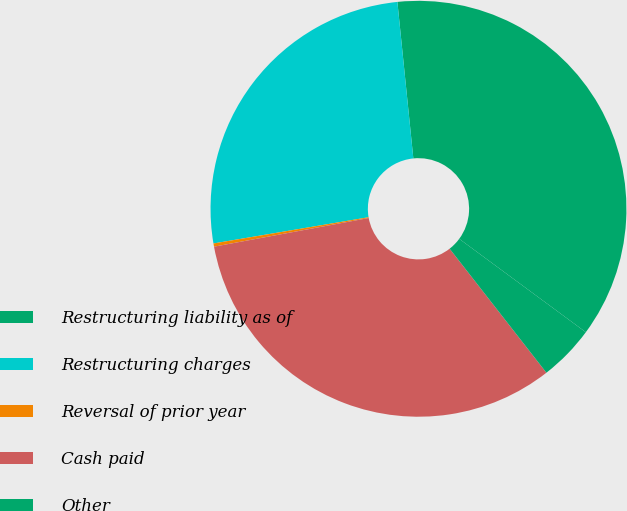<chart> <loc_0><loc_0><loc_500><loc_500><pie_chart><fcel>Restructuring liability as of<fcel>Restructuring charges<fcel>Reversal of prior year<fcel>Cash paid<fcel>Other<nl><fcel>36.73%<fcel>26.05%<fcel>0.25%<fcel>32.63%<fcel>4.34%<nl></chart> 